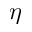<formula> <loc_0><loc_0><loc_500><loc_500>\eta</formula> 